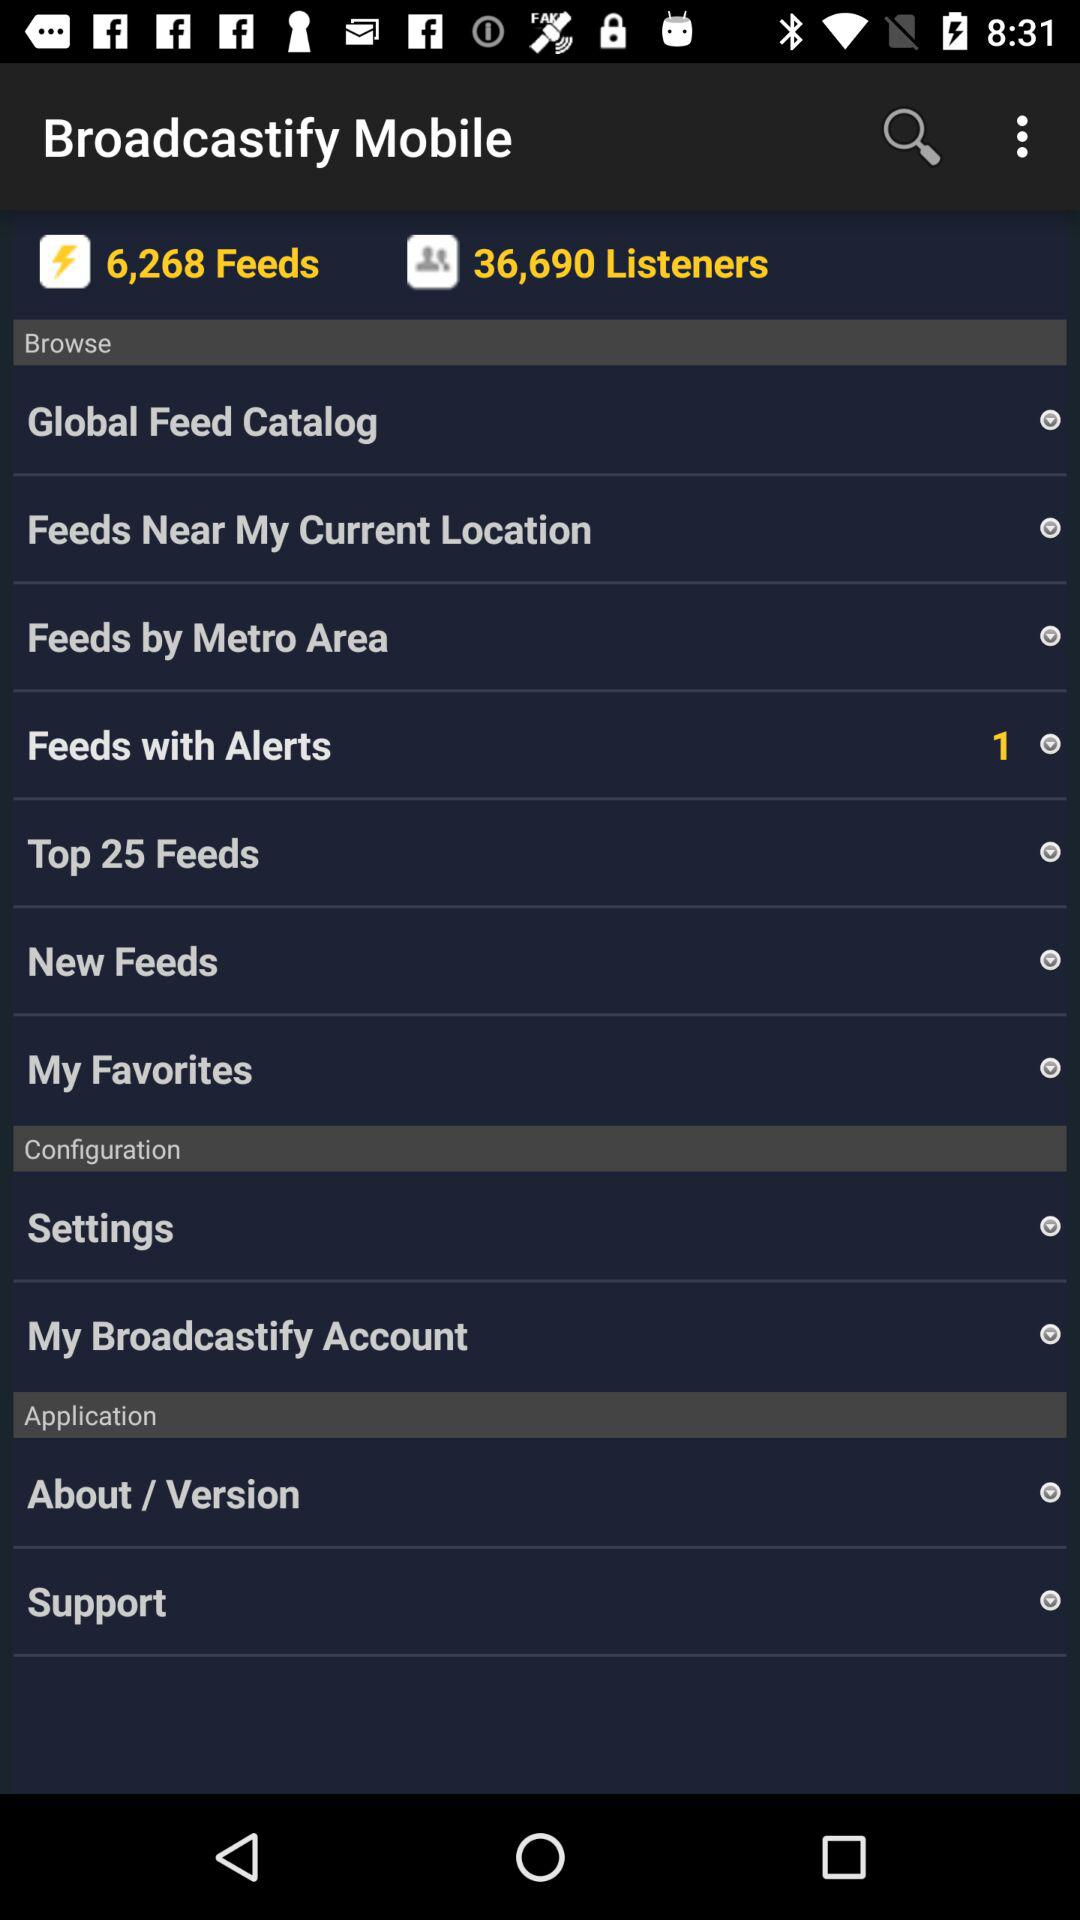How many feeds in total are there? The total number of feeds is 6,268. 